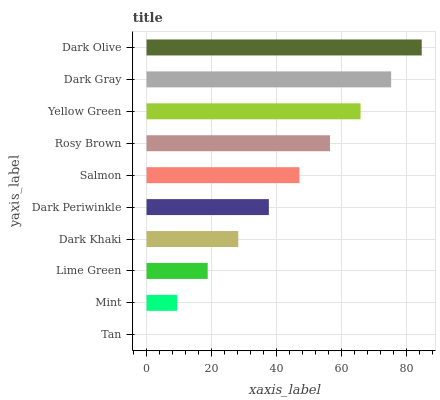Is Tan the minimum?
Answer yes or no. Yes. Is Dark Olive the maximum?
Answer yes or no. Yes. Is Mint the minimum?
Answer yes or no. No. Is Mint the maximum?
Answer yes or no. No. Is Mint greater than Tan?
Answer yes or no. Yes. Is Tan less than Mint?
Answer yes or no. Yes. Is Tan greater than Mint?
Answer yes or no. No. Is Mint less than Tan?
Answer yes or no. No. Is Salmon the high median?
Answer yes or no. Yes. Is Dark Periwinkle the low median?
Answer yes or no. Yes. Is Tan the high median?
Answer yes or no. No. Is Yellow Green the low median?
Answer yes or no. No. 